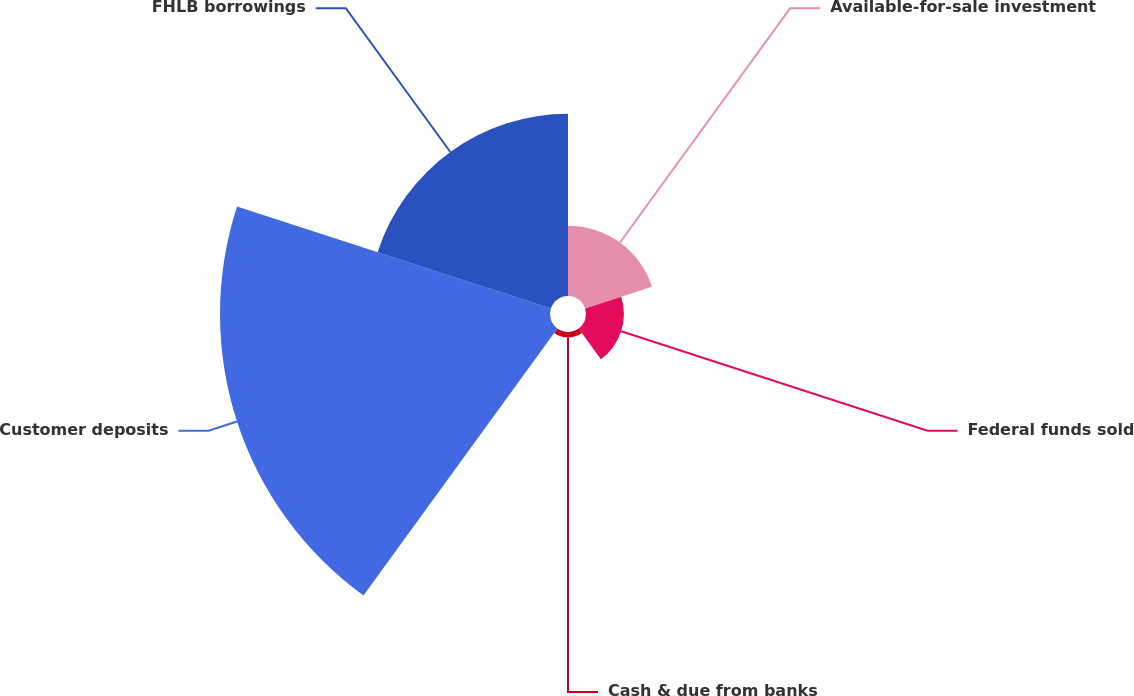<chart> <loc_0><loc_0><loc_500><loc_500><pie_chart><fcel>Available-for-sale investment<fcel>Federal funds sold<fcel>Cash & due from banks<fcel>Customer deposits<fcel>FHLB borrowings<nl><fcel>11.24%<fcel>6.06%<fcel>0.87%<fcel>52.72%<fcel>29.11%<nl></chart> 